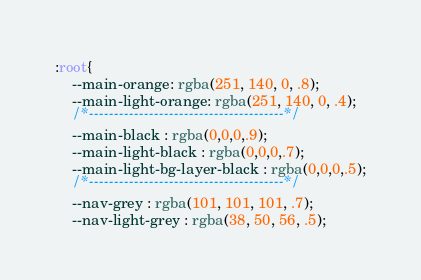<code> <loc_0><loc_0><loc_500><loc_500><_CSS_>:root{
    --main-orange: rgba(251, 140, 0, .8);
    --main-light-orange: rgba(251, 140, 0, .4);
    /*---------------------------------------*/
    --main-black : rgba(0,0,0,.9);
    --main-light-black : rgba(0,0,0,.7);
    --main-light-bg-layer-black : rgba(0,0,0,.5);
    /*---------------------------------------*/
    --nav-grey : rgba(101, 101, 101, .7);
    --nav-light-grey : rgba(38, 50, 56, .5);</code> 